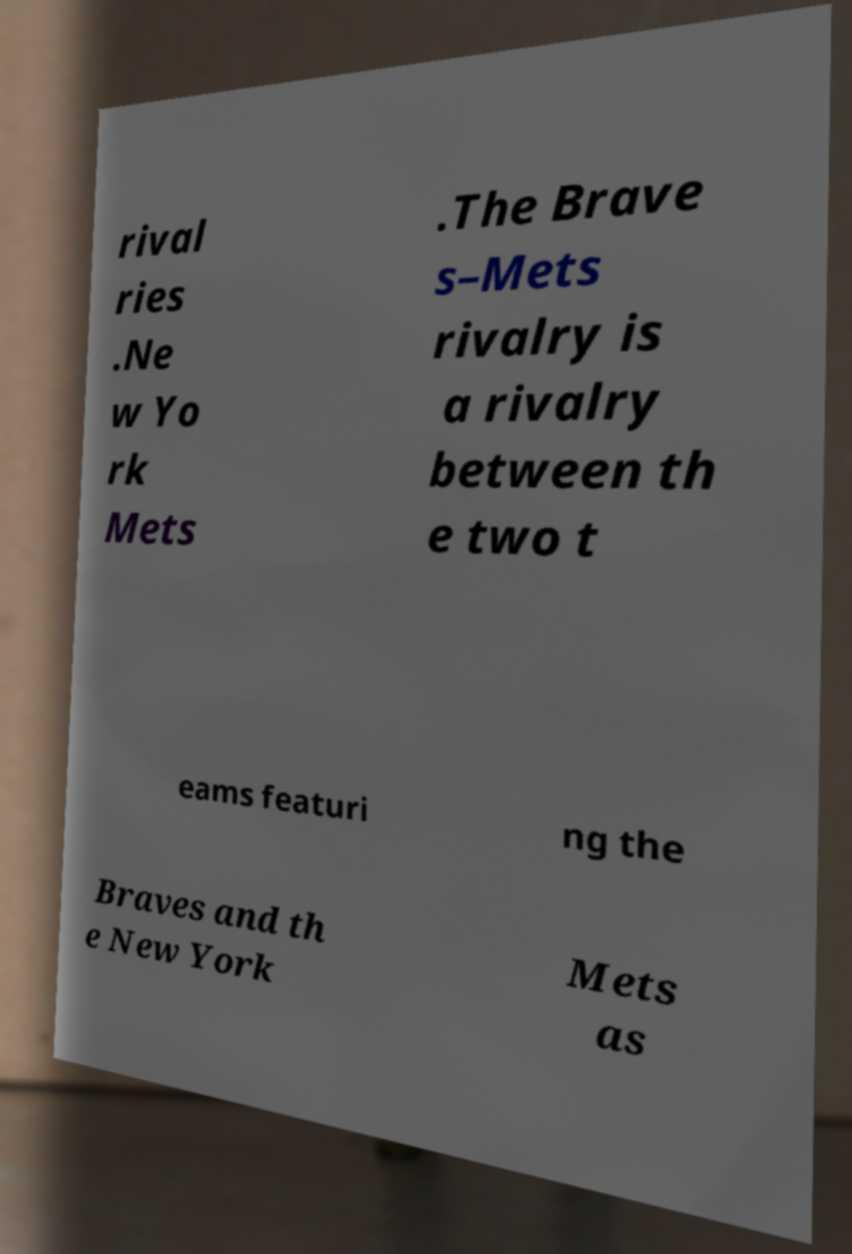There's text embedded in this image that I need extracted. Can you transcribe it verbatim? rival ries .Ne w Yo rk Mets .The Brave s–Mets rivalry is a rivalry between th e two t eams featuri ng the Braves and th e New York Mets as 